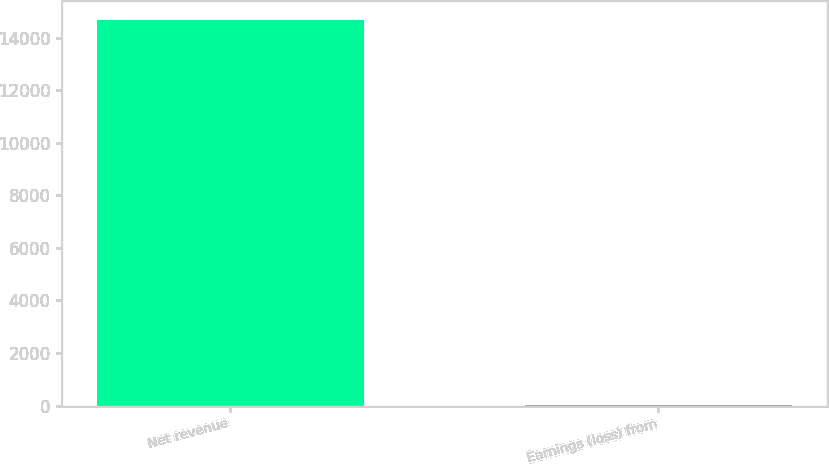Convert chart to OTSL. <chart><loc_0><loc_0><loc_500><loc_500><bar_chart><fcel>Net revenue<fcel>Earnings (loss) from<nl><fcel>14680<fcel>1.6<nl></chart> 